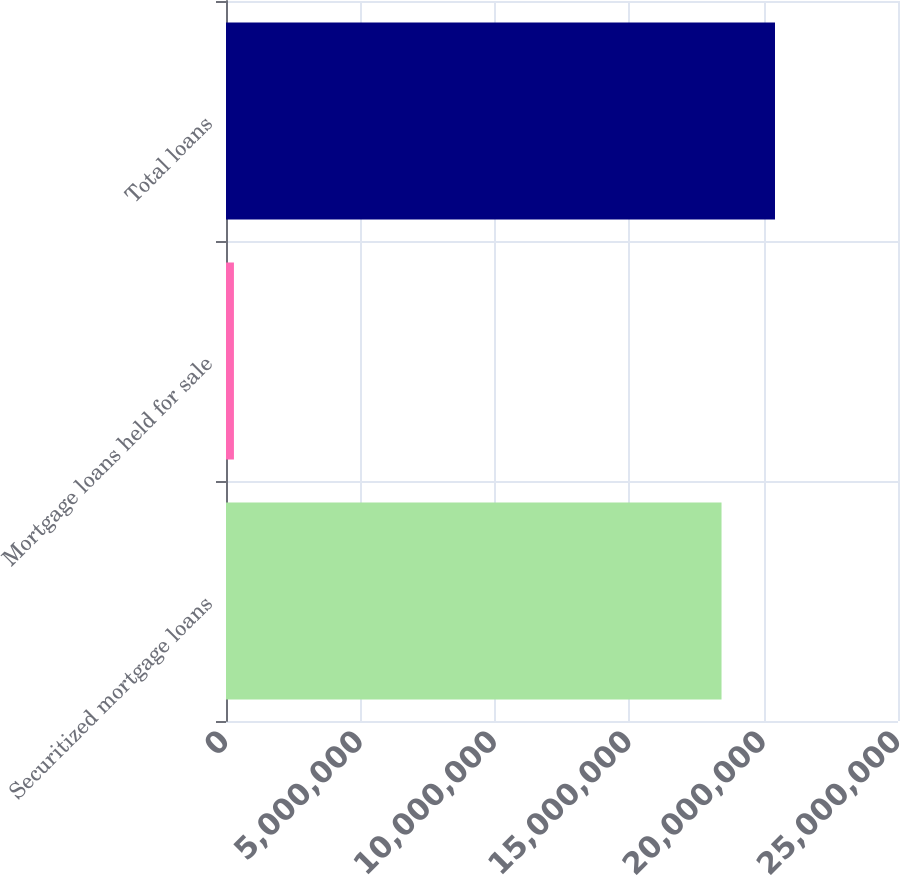<chart> <loc_0><loc_0><loc_500><loc_500><bar_chart><fcel>Securitized mortgage loans<fcel>Mortgage loans held for sale<fcel>Total loans<nl><fcel>1.84349e+07<fcel>295208<fcel>2.0424e+07<nl></chart> 